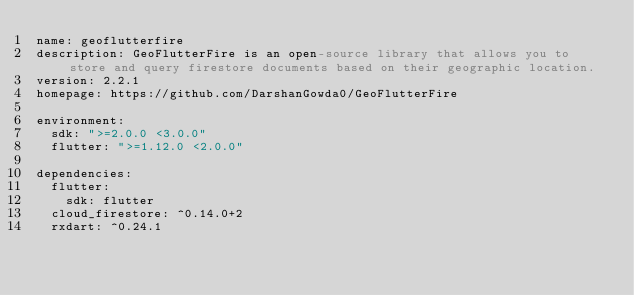<code> <loc_0><loc_0><loc_500><loc_500><_YAML_>name: geoflutterfire
description: GeoFlutterFire is an open-source library that allows you to store and query firestore documents based on their geographic location.
version: 2.2.1
homepage: https://github.com/DarshanGowda0/GeoFlutterFire

environment:
  sdk: ">=2.0.0 <3.0.0"
  flutter: ">=1.12.0 <2.0.0"

dependencies:
  flutter:
    sdk: flutter
  cloud_firestore: ^0.14.0+2
  rxdart: ^0.24.1
</code> 